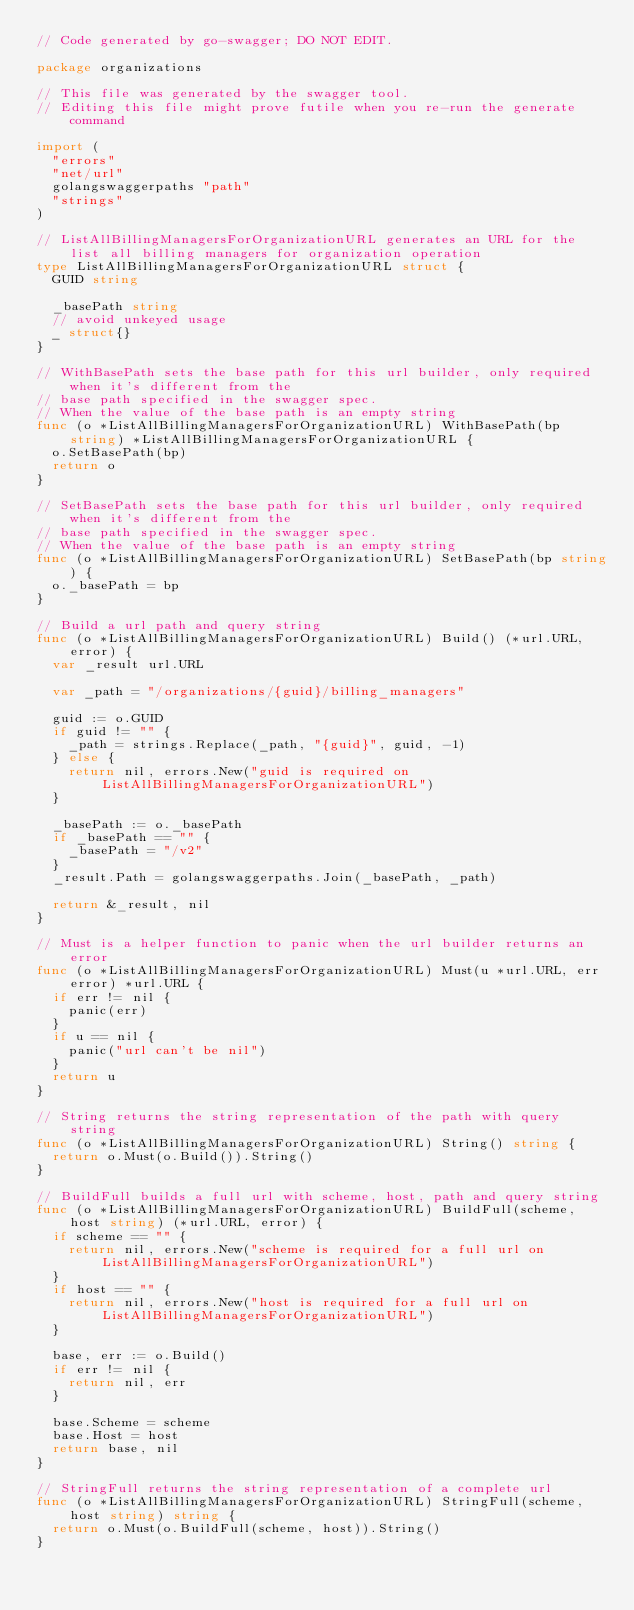<code> <loc_0><loc_0><loc_500><loc_500><_Go_>// Code generated by go-swagger; DO NOT EDIT.

package organizations

// This file was generated by the swagger tool.
// Editing this file might prove futile when you re-run the generate command

import (
	"errors"
	"net/url"
	golangswaggerpaths "path"
	"strings"
)

// ListAllBillingManagersForOrganizationURL generates an URL for the list all billing managers for organization operation
type ListAllBillingManagersForOrganizationURL struct {
	GUID string

	_basePath string
	// avoid unkeyed usage
	_ struct{}
}

// WithBasePath sets the base path for this url builder, only required when it's different from the
// base path specified in the swagger spec.
// When the value of the base path is an empty string
func (o *ListAllBillingManagersForOrganizationURL) WithBasePath(bp string) *ListAllBillingManagersForOrganizationURL {
	o.SetBasePath(bp)
	return o
}

// SetBasePath sets the base path for this url builder, only required when it's different from the
// base path specified in the swagger spec.
// When the value of the base path is an empty string
func (o *ListAllBillingManagersForOrganizationURL) SetBasePath(bp string) {
	o._basePath = bp
}

// Build a url path and query string
func (o *ListAllBillingManagersForOrganizationURL) Build() (*url.URL, error) {
	var _result url.URL

	var _path = "/organizations/{guid}/billing_managers"

	guid := o.GUID
	if guid != "" {
		_path = strings.Replace(_path, "{guid}", guid, -1)
	} else {
		return nil, errors.New("guid is required on ListAllBillingManagersForOrganizationURL")
	}

	_basePath := o._basePath
	if _basePath == "" {
		_basePath = "/v2"
	}
	_result.Path = golangswaggerpaths.Join(_basePath, _path)

	return &_result, nil
}

// Must is a helper function to panic when the url builder returns an error
func (o *ListAllBillingManagersForOrganizationURL) Must(u *url.URL, err error) *url.URL {
	if err != nil {
		panic(err)
	}
	if u == nil {
		panic("url can't be nil")
	}
	return u
}

// String returns the string representation of the path with query string
func (o *ListAllBillingManagersForOrganizationURL) String() string {
	return o.Must(o.Build()).String()
}

// BuildFull builds a full url with scheme, host, path and query string
func (o *ListAllBillingManagersForOrganizationURL) BuildFull(scheme, host string) (*url.URL, error) {
	if scheme == "" {
		return nil, errors.New("scheme is required for a full url on ListAllBillingManagersForOrganizationURL")
	}
	if host == "" {
		return nil, errors.New("host is required for a full url on ListAllBillingManagersForOrganizationURL")
	}

	base, err := o.Build()
	if err != nil {
		return nil, err
	}

	base.Scheme = scheme
	base.Host = host
	return base, nil
}

// StringFull returns the string representation of a complete url
func (o *ListAllBillingManagersForOrganizationURL) StringFull(scheme, host string) string {
	return o.Must(o.BuildFull(scheme, host)).String()
}
</code> 